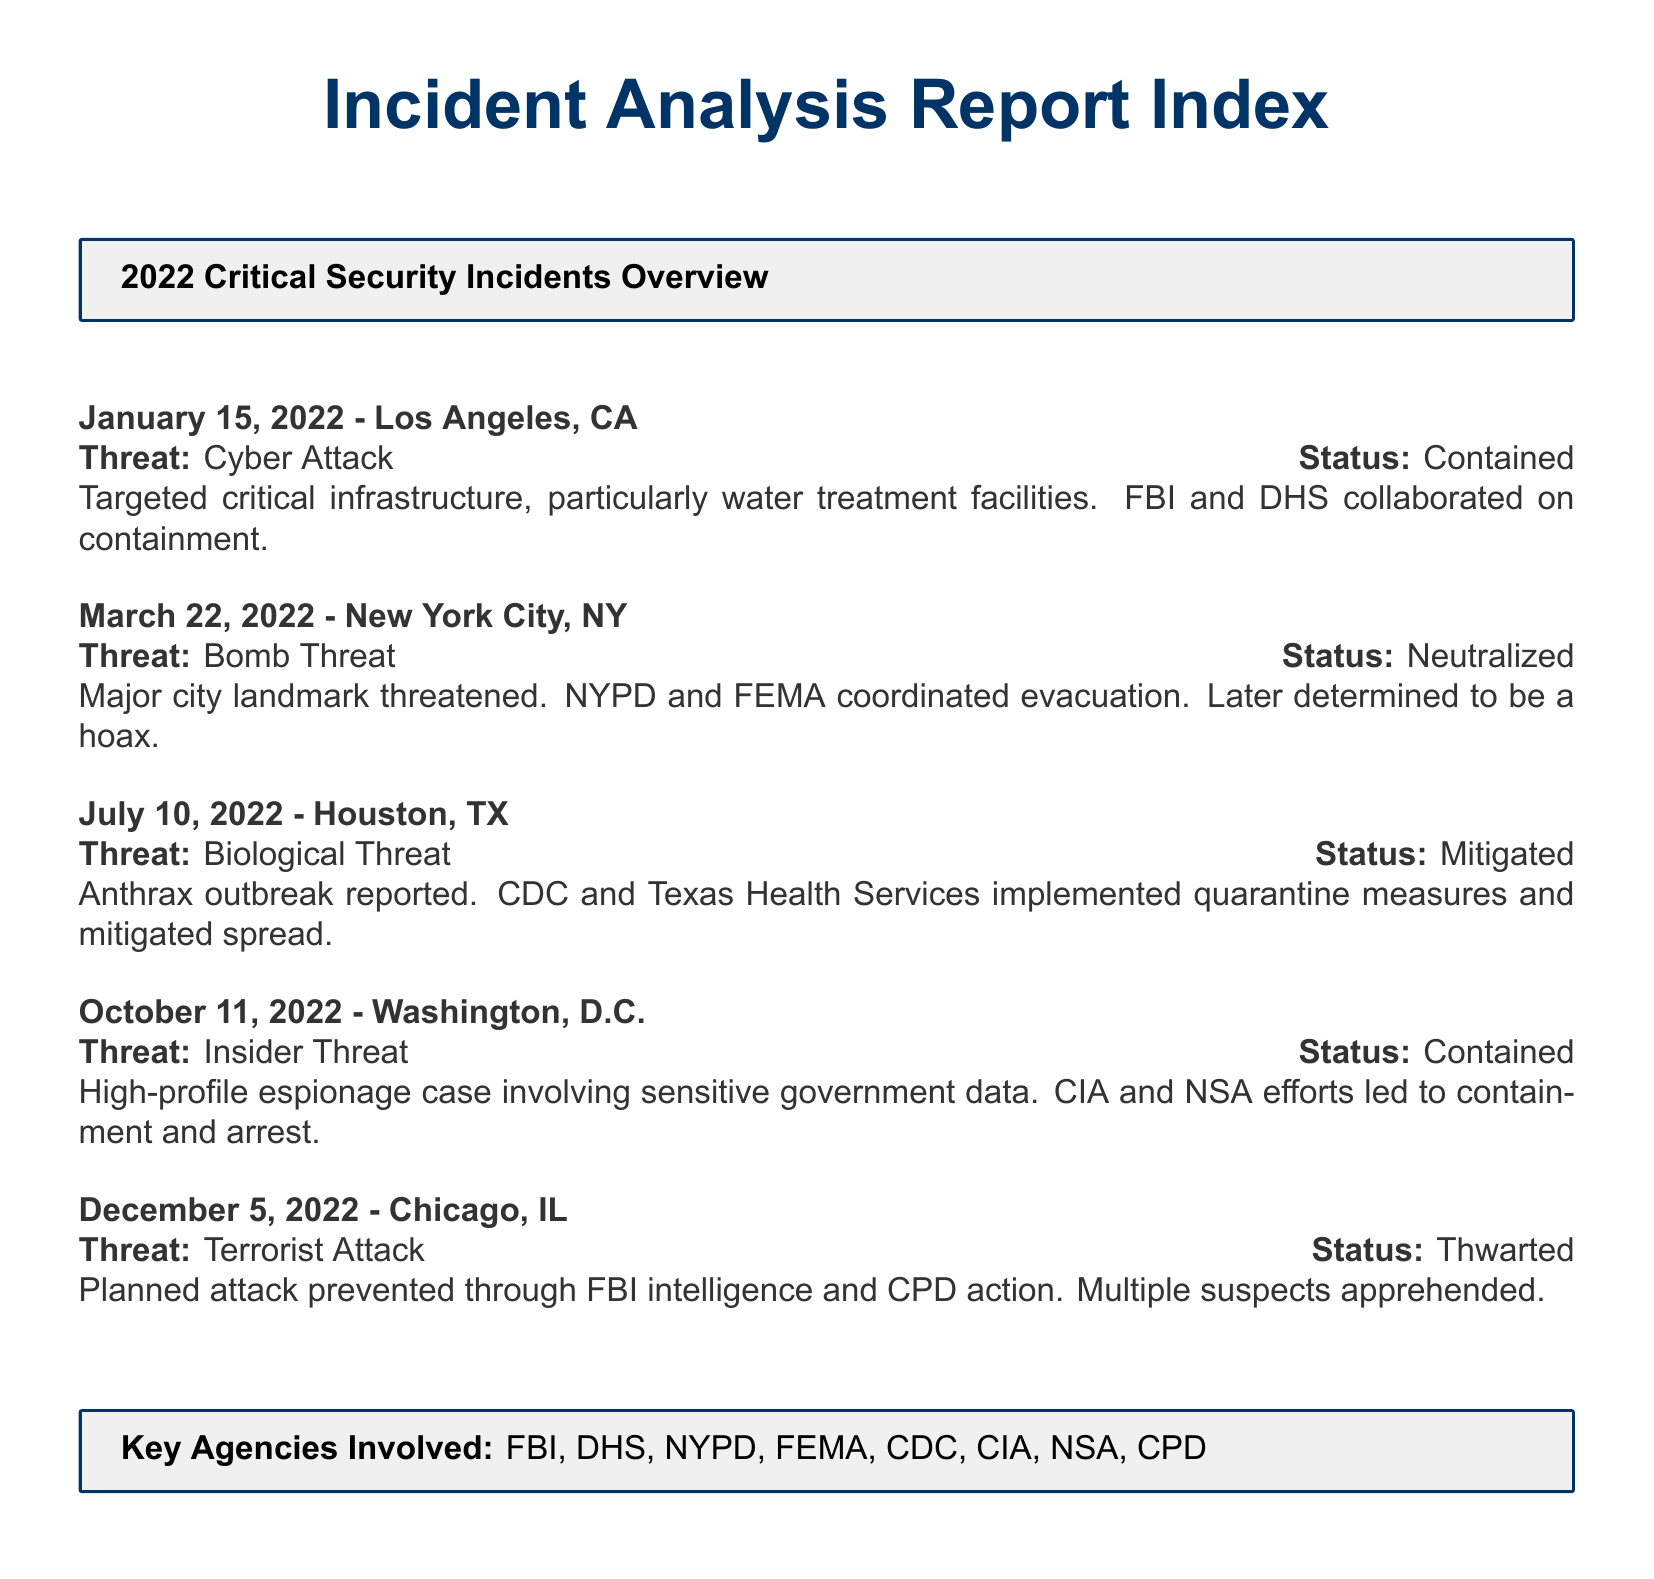What was the date of the cyber attack in Los Angeles? The document states the incident occurred on January 15, 2022.
Answer: January 15, 2022 Which agency collaborated on the containment of the cyber attack? The FBI and DHS were involved in the containment effort as mentioned in the context of the incident.
Answer: FBI and DHS What type of threat was reported in Houston on July 10, 2022? The report specifies that a biological threat related to an anthrax outbreak was the focus of this incident.
Answer: Biological Threat How was the bomb threat in New York City resolved? The document notes that the threat was neutralized after determining it to be a hoax.
Answer: Neutralized What was the status of the terrorist attack planned in Chicago? The report indicates that the planned attack was thwarted, preventing any occurrence of the attack.
Answer: Thwarted Which event involved the arrest of individuals associated with espionage? The insider threat incident detailed in Washington, D.C. resulted in containment and arrest.
Answer: Insider Threat What is the common element in the resolution status of the incidents listed? Upon review, it is clear that all incidents were either contained, neutralized, mitigated, or thwarted.
Answer: Contained, Neutralized, Mitigated, Thwarted What type of incident was reported on October 11, 2022? The report outlines an insider threat incident which involves sensitive government data.
Answer: Insider Threat 